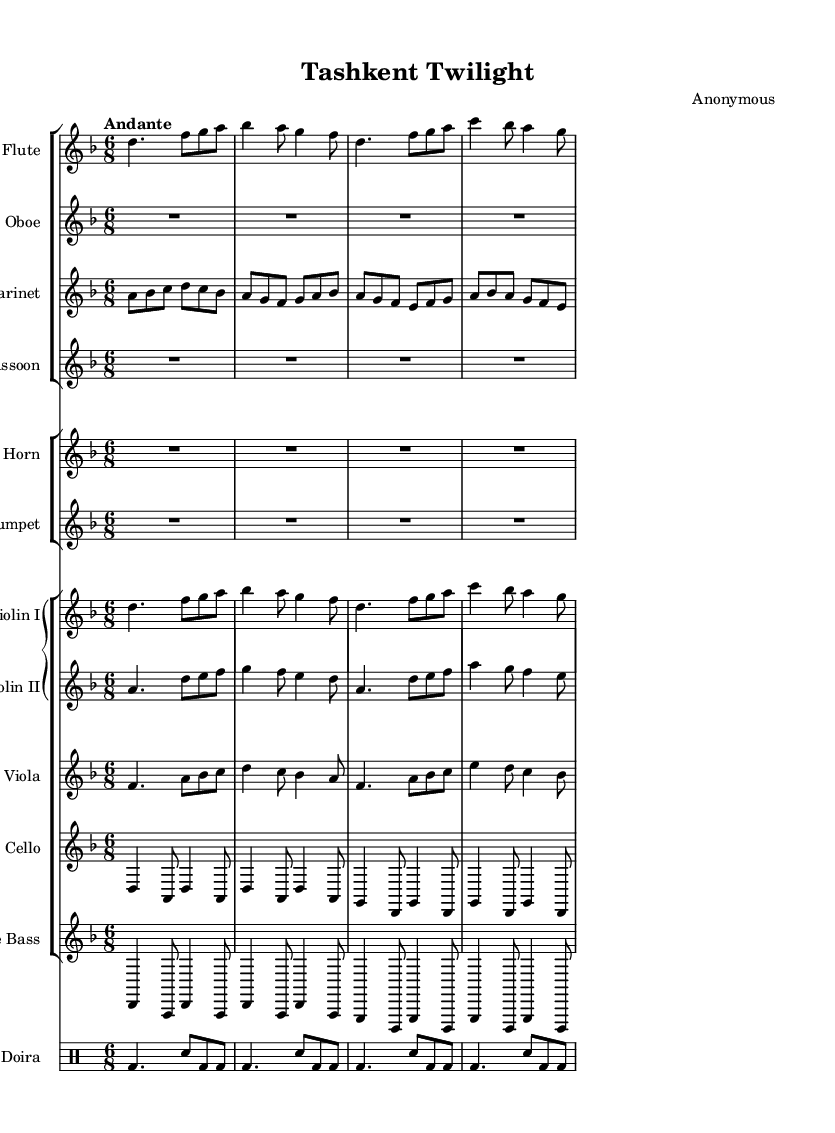What is the key signature of this music? The key signature is D minor, which typically has one flat (B flat). It can be confirmed by looking at the key signature indicated at the beginning of the staff.
Answer: D minor What is the time signature of this piece? The time signature is 6/8, which means there are six eighth notes in each measure. This can be identified by the fraction at the beginning of the score.
Answer: 6/8 What is the tempo marking for this symphonic work? The tempo marking is "Andante," which indicates a moderate walking pace. This is generally indicated at the beginning of the score, in the tempo section.
Answer: Andante How many players are in the woodwind section? There are four players in the woodwind section: flute, oboe, clarinet, and bassoon. This can be determined by counting the number of individual lines in the woodwind staff group.
Answer: Four What instruments are playing traditional Uzbek rhythms? The doira is playing traditional Uzbek rhythms, as it is a regional percussion instrument included in the score and is indicated as a drum part.
Answer: Doira Which instrument has the highest register in this symphony? The flute has the highest register in this symphony, as it is typically tuned to a higher pitch compared to other instruments like clarinets or violins. This can be assessed by looking at the standard range of each instrument.
Answer: Flute What instruments follow the western orchestration in this symphony? The strings, including violins, viola, cello, and double bass, follow the western orchestration, as they adhere to traditional western symphonic formats. This can be recognized by their placement in a Grand Staff and typical western orchestral arrangement.
Answer: Strings 